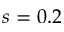<formula> <loc_0><loc_0><loc_500><loc_500>s = 0 . 2</formula> 